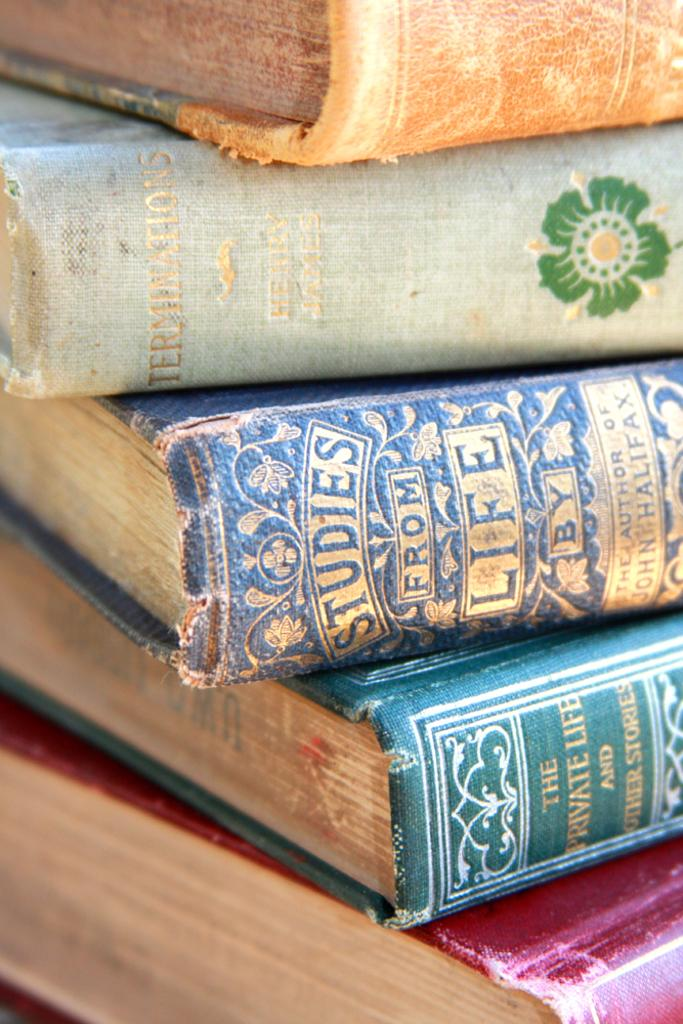<image>
Describe the image concisely. A stack of books includes a blue one titled Studies From Life. 